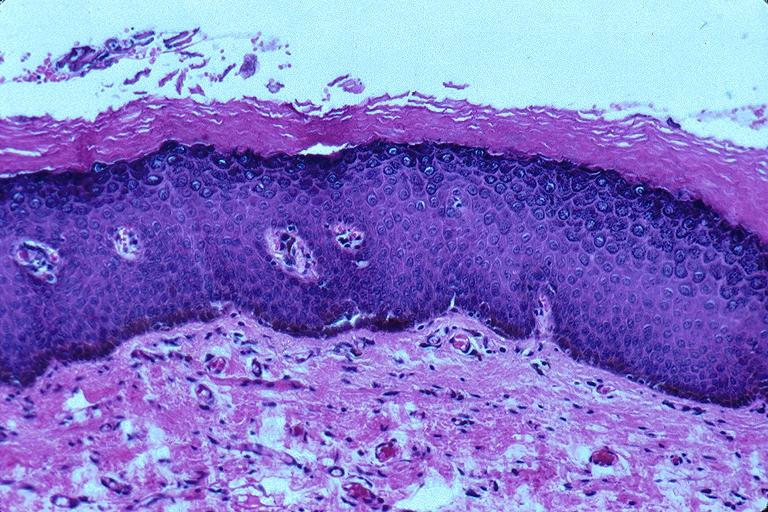s oral present?
Answer the question using a single word or phrase. Yes 